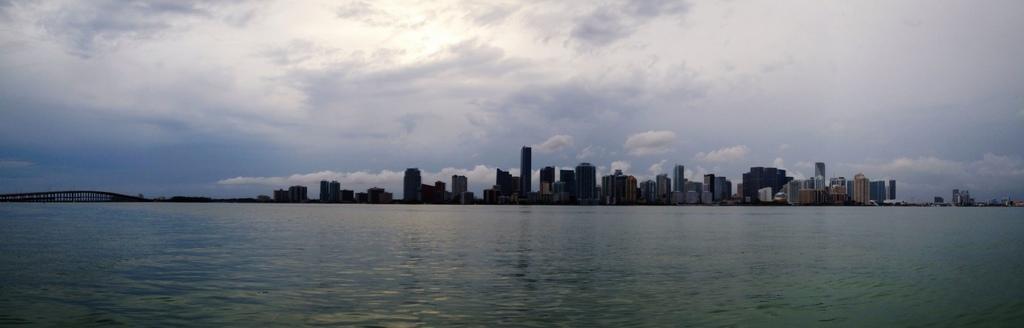In one or two sentences, can you explain what this image depicts? In this picture there is water at the bottom side of the image and there are buildings in the center of the image. 